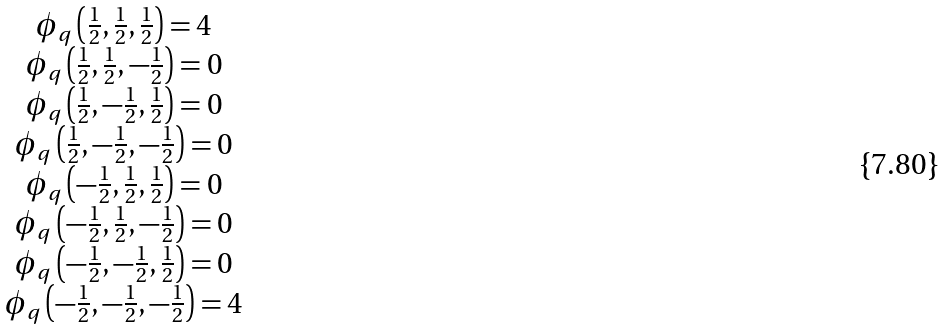<formula> <loc_0><loc_0><loc_500><loc_500>\begin{array} { c } \phi _ { q } \left ( \frac { 1 } { 2 } , \frac { 1 } { 2 } , \frac { 1 } { 2 } \right ) = 4 \\ \phi _ { q } \left ( \frac { 1 } { 2 } , \frac { 1 } { 2 } , - \frac { 1 } { 2 } \right ) = 0 \\ \phi _ { q } \left ( \frac { 1 } { 2 } , - \frac { 1 } { 2 } , \frac { 1 } { 2 } \right ) = 0 \\ \phi _ { q } \left ( \frac { 1 } { 2 } , - \frac { 1 } { 2 } , - \frac { 1 } { 2 } \right ) = 0 \\ \phi _ { q } \left ( - \frac { 1 } { 2 } , \frac { 1 } { 2 } , \frac { 1 } { 2 } \right ) = 0 \\ \phi _ { q } \left ( - \frac { 1 } { 2 } , \frac { 1 } { 2 } , - \frac { 1 } { 2 } \right ) = 0 \\ \phi _ { q } \left ( - \frac { 1 } { 2 } , - \frac { 1 } { 2 } , \frac { 1 } { 2 } \right ) = 0 \\ \phi _ { q } \left ( - \frac { 1 } { 2 } , - \frac { 1 } { 2 } , - \frac { 1 } { 2 } \right ) = 4 \end{array}</formula> 